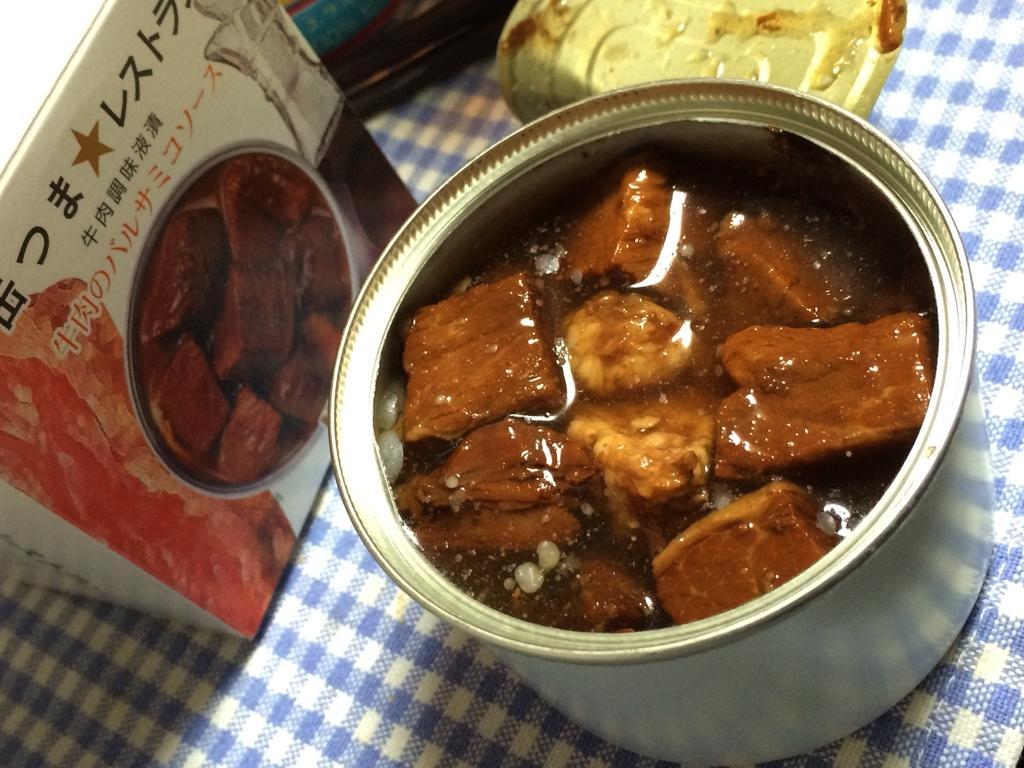Can you describe this image briefly? In this picture we can see the liquid and some food items in a small container. We can see a box, other objects and a cloth. 